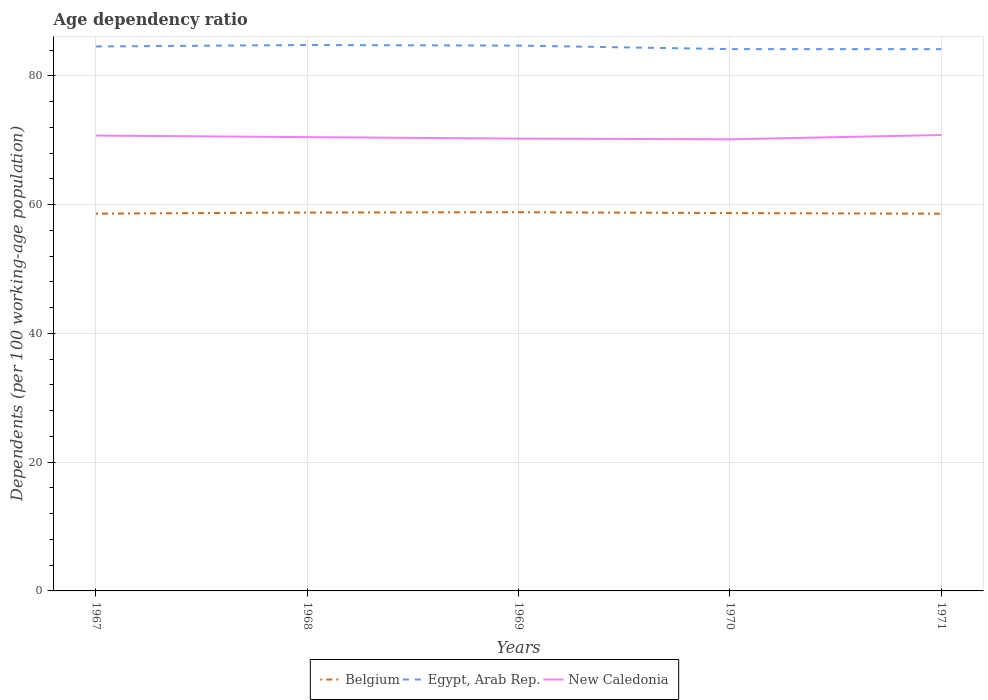Is the number of lines equal to the number of legend labels?
Ensure brevity in your answer.  Yes. Across all years, what is the maximum age dependency ratio in in Belgium?
Ensure brevity in your answer.  58.59. In which year was the age dependency ratio in in New Caledonia maximum?
Your answer should be very brief. 1970. What is the total age dependency ratio in in Belgium in the graph?
Ensure brevity in your answer.  -0.09. What is the difference between the highest and the second highest age dependency ratio in in New Caledonia?
Keep it short and to the point. 0.67. What is the difference between the highest and the lowest age dependency ratio in in Egypt, Arab Rep.?
Your answer should be compact. 3. Is the age dependency ratio in in Belgium strictly greater than the age dependency ratio in in Egypt, Arab Rep. over the years?
Your answer should be very brief. Yes. How many lines are there?
Offer a terse response. 3. Are the values on the major ticks of Y-axis written in scientific E-notation?
Your answer should be compact. No. Does the graph contain grids?
Your answer should be very brief. Yes. Where does the legend appear in the graph?
Offer a very short reply. Bottom center. What is the title of the graph?
Give a very brief answer. Age dependency ratio. What is the label or title of the X-axis?
Give a very brief answer. Years. What is the label or title of the Y-axis?
Offer a terse response. Dependents (per 100 working-age population). What is the Dependents (per 100 working-age population) of Belgium in 1967?
Your response must be concise. 58.6. What is the Dependents (per 100 working-age population) of Egypt, Arab Rep. in 1967?
Make the answer very short. 84.56. What is the Dependents (per 100 working-age population) in New Caledonia in 1967?
Your response must be concise. 70.73. What is the Dependents (per 100 working-age population) in Belgium in 1968?
Your answer should be very brief. 58.77. What is the Dependents (per 100 working-age population) of Egypt, Arab Rep. in 1968?
Provide a succinct answer. 84.79. What is the Dependents (per 100 working-age population) in New Caledonia in 1968?
Provide a succinct answer. 70.48. What is the Dependents (per 100 working-age population) in Belgium in 1969?
Ensure brevity in your answer.  58.82. What is the Dependents (per 100 working-age population) in Egypt, Arab Rep. in 1969?
Give a very brief answer. 84.7. What is the Dependents (per 100 working-age population) of New Caledonia in 1969?
Provide a succinct answer. 70.25. What is the Dependents (per 100 working-age population) in Belgium in 1970?
Offer a very short reply. 58.69. What is the Dependents (per 100 working-age population) of Egypt, Arab Rep. in 1970?
Your response must be concise. 84.16. What is the Dependents (per 100 working-age population) of New Caledonia in 1970?
Offer a terse response. 70.15. What is the Dependents (per 100 working-age population) of Belgium in 1971?
Offer a very short reply. 58.59. What is the Dependents (per 100 working-age population) of Egypt, Arab Rep. in 1971?
Keep it short and to the point. 84.15. What is the Dependents (per 100 working-age population) in New Caledonia in 1971?
Provide a short and direct response. 70.81. Across all years, what is the maximum Dependents (per 100 working-age population) of Belgium?
Offer a terse response. 58.82. Across all years, what is the maximum Dependents (per 100 working-age population) of Egypt, Arab Rep.?
Give a very brief answer. 84.79. Across all years, what is the maximum Dependents (per 100 working-age population) in New Caledonia?
Your answer should be very brief. 70.81. Across all years, what is the minimum Dependents (per 100 working-age population) of Belgium?
Your answer should be compact. 58.59. Across all years, what is the minimum Dependents (per 100 working-age population) in Egypt, Arab Rep.?
Offer a very short reply. 84.15. Across all years, what is the minimum Dependents (per 100 working-age population) of New Caledonia?
Your response must be concise. 70.15. What is the total Dependents (per 100 working-age population) in Belgium in the graph?
Your answer should be compact. 293.48. What is the total Dependents (per 100 working-age population) of Egypt, Arab Rep. in the graph?
Keep it short and to the point. 422.36. What is the total Dependents (per 100 working-age population) in New Caledonia in the graph?
Your response must be concise. 352.43. What is the difference between the Dependents (per 100 working-age population) of Belgium in 1967 and that in 1968?
Keep it short and to the point. -0.17. What is the difference between the Dependents (per 100 working-age population) of Egypt, Arab Rep. in 1967 and that in 1968?
Your answer should be very brief. -0.23. What is the difference between the Dependents (per 100 working-age population) in New Caledonia in 1967 and that in 1968?
Provide a short and direct response. 0.25. What is the difference between the Dependents (per 100 working-age population) of Belgium in 1967 and that in 1969?
Offer a very short reply. -0.22. What is the difference between the Dependents (per 100 working-age population) in Egypt, Arab Rep. in 1967 and that in 1969?
Keep it short and to the point. -0.13. What is the difference between the Dependents (per 100 working-age population) of New Caledonia in 1967 and that in 1969?
Offer a very short reply. 0.48. What is the difference between the Dependents (per 100 working-age population) in Belgium in 1967 and that in 1970?
Offer a very short reply. -0.09. What is the difference between the Dependents (per 100 working-age population) in Egypt, Arab Rep. in 1967 and that in 1970?
Make the answer very short. 0.41. What is the difference between the Dependents (per 100 working-age population) in New Caledonia in 1967 and that in 1970?
Give a very brief answer. 0.58. What is the difference between the Dependents (per 100 working-age population) of Belgium in 1967 and that in 1971?
Provide a succinct answer. 0.01. What is the difference between the Dependents (per 100 working-age population) of Egypt, Arab Rep. in 1967 and that in 1971?
Offer a terse response. 0.41. What is the difference between the Dependents (per 100 working-age population) in New Caledonia in 1967 and that in 1971?
Provide a short and direct response. -0.08. What is the difference between the Dependents (per 100 working-age population) of Belgium in 1968 and that in 1969?
Provide a short and direct response. -0.05. What is the difference between the Dependents (per 100 working-age population) in Egypt, Arab Rep. in 1968 and that in 1969?
Offer a terse response. 0.09. What is the difference between the Dependents (per 100 working-age population) in New Caledonia in 1968 and that in 1969?
Keep it short and to the point. 0.23. What is the difference between the Dependents (per 100 working-age population) of Belgium in 1968 and that in 1970?
Your answer should be very brief. 0.08. What is the difference between the Dependents (per 100 working-age population) in Egypt, Arab Rep. in 1968 and that in 1970?
Ensure brevity in your answer.  0.63. What is the difference between the Dependents (per 100 working-age population) in New Caledonia in 1968 and that in 1970?
Provide a succinct answer. 0.34. What is the difference between the Dependents (per 100 working-age population) of Belgium in 1968 and that in 1971?
Offer a very short reply. 0.18. What is the difference between the Dependents (per 100 working-age population) of Egypt, Arab Rep. in 1968 and that in 1971?
Your response must be concise. 0.64. What is the difference between the Dependents (per 100 working-age population) in New Caledonia in 1968 and that in 1971?
Offer a very short reply. -0.33. What is the difference between the Dependents (per 100 working-age population) of Belgium in 1969 and that in 1970?
Provide a short and direct response. 0.13. What is the difference between the Dependents (per 100 working-age population) of Egypt, Arab Rep. in 1969 and that in 1970?
Your response must be concise. 0.54. What is the difference between the Dependents (per 100 working-age population) of New Caledonia in 1969 and that in 1970?
Your answer should be compact. 0.11. What is the difference between the Dependents (per 100 working-age population) of Belgium in 1969 and that in 1971?
Offer a very short reply. 0.23. What is the difference between the Dependents (per 100 working-age population) in Egypt, Arab Rep. in 1969 and that in 1971?
Provide a short and direct response. 0.55. What is the difference between the Dependents (per 100 working-age population) of New Caledonia in 1969 and that in 1971?
Provide a succinct answer. -0.56. What is the difference between the Dependents (per 100 working-age population) in Belgium in 1970 and that in 1971?
Provide a succinct answer. 0.1. What is the difference between the Dependents (per 100 working-age population) of Egypt, Arab Rep. in 1970 and that in 1971?
Your response must be concise. 0.01. What is the difference between the Dependents (per 100 working-age population) in New Caledonia in 1970 and that in 1971?
Provide a short and direct response. -0.67. What is the difference between the Dependents (per 100 working-age population) of Belgium in 1967 and the Dependents (per 100 working-age population) of Egypt, Arab Rep. in 1968?
Your response must be concise. -26.19. What is the difference between the Dependents (per 100 working-age population) of Belgium in 1967 and the Dependents (per 100 working-age population) of New Caledonia in 1968?
Give a very brief answer. -11.88. What is the difference between the Dependents (per 100 working-age population) of Egypt, Arab Rep. in 1967 and the Dependents (per 100 working-age population) of New Caledonia in 1968?
Ensure brevity in your answer.  14.08. What is the difference between the Dependents (per 100 working-age population) in Belgium in 1967 and the Dependents (per 100 working-age population) in Egypt, Arab Rep. in 1969?
Your response must be concise. -26.1. What is the difference between the Dependents (per 100 working-age population) in Belgium in 1967 and the Dependents (per 100 working-age population) in New Caledonia in 1969?
Offer a very short reply. -11.65. What is the difference between the Dependents (per 100 working-age population) of Egypt, Arab Rep. in 1967 and the Dependents (per 100 working-age population) of New Caledonia in 1969?
Keep it short and to the point. 14.31. What is the difference between the Dependents (per 100 working-age population) in Belgium in 1967 and the Dependents (per 100 working-age population) in Egypt, Arab Rep. in 1970?
Your response must be concise. -25.56. What is the difference between the Dependents (per 100 working-age population) in Belgium in 1967 and the Dependents (per 100 working-age population) in New Caledonia in 1970?
Make the answer very short. -11.54. What is the difference between the Dependents (per 100 working-age population) in Egypt, Arab Rep. in 1967 and the Dependents (per 100 working-age population) in New Caledonia in 1970?
Keep it short and to the point. 14.42. What is the difference between the Dependents (per 100 working-age population) in Belgium in 1967 and the Dependents (per 100 working-age population) in Egypt, Arab Rep. in 1971?
Keep it short and to the point. -25.55. What is the difference between the Dependents (per 100 working-age population) of Belgium in 1967 and the Dependents (per 100 working-age population) of New Caledonia in 1971?
Provide a short and direct response. -12.21. What is the difference between the Dependents (per 100 working-age population) of Egypt, Arab Rep. in 1967 and the Dependents (per 100 working-age population) of New Caledonia in 1971?
Your answer should be compact. 13.75. What is the difference between the Dependents (per 100 working-age population) of Belgium in 1968 and the Dependents (per 100 working-age population) of Egypt, Arab Rep. in 1969?
Your answer should be very brief. -25.92. What is the difference between the Dependents (per 100 working-age population) in Belgium in 1968 and the Dependents (per 100 working-age population) in New Caledonia in 1969?
Provide a short and direct response. -11.48. What is the difference between the Dependents (per 100 working-age population) of Egypt, Arab Rep. in 1968 and the Dependents (per 100 working-age population) of New Caledonia in 1969?
Offer a terse response. 14.54. What is the difference between the Dependents (per 100 working-age population) in Belgium in 1968 and the Dependents (per 100 working-age population) in Egypt, Arab Rep. in 1970?
Your answer should be compact. -25.38. What is the difference between the Dependents (per 100 working-age population) of Belgium in 1968 and the Dependents (per 100 working-age population) of New Caledonia in 1970?
Offer a very short reply. -11.37. What is the difference between the Dependents (per 100 working-age population) of Egypt, Arab Rep. in 1968 and the Dependents (per 100 working-age population) of New Caledonia in 1970?
Make the answer very short. 14.65. What is the difference between the Dependents (per 100 working-age population) in Belgium in 1968 and the Dependents (per 100 working-age population) in Egypt, Arab Rep. in 1971?
Provide a succinct answer. -25.38. What is the difference between the Dependents (per 100 working-age population) of Belgium in 1968 and the Dependents (per 100 working-age population) of New Caledonia in 1971?
Your answer should be compact. -12.04. What is the difference between the Dependents (per 100 working-age population) of Egypt, Arab Rep. in 1968 and the Dependents (per 100 working-age population) of New Caledonia in 1971?
Your response must be concise. 13.98. What is the difference between the Dependents (per 100 working-age population) of Belgium in 1969 and the Dependents (per 100 working-age population) of Egypt, Arab Rep. in 1970?
Ensure brevity in your answer.  -25.34. What is the difference between the Dependents (per 100 working-age population) in Belgium in 1969 and the Dependents (per 100 working-age population) in New Caledonia in 1970?
Provide a short and direct response. -11.33. What is the difference between the Dependents (per 100 working-age population) of Egypt, Arab Rep. in 1969 and the Dependents (per 100 working-age population) of New Caledonia in 1970?
Keep it short and to the point. 14.55. What is the difference between the Dependents (per 100 working-age population) of Belgium in 1969 and the Dependents (per 100 working-age population) of Egypt, Arab Rep. in 1971?
Keep it short and to the point. -25.33. What is the difference between the Dependents (per 100 working-age population) in Belgium in 1969 and the Dependents (per 100 working-age population) in New Caledonia in 1971?
Offer a very short reply. -11.99. What is the difference between the Dependents (per 100 working-age population) of Egypt, Arab Rep. in 1969 and the Dependents (per 100 working-age population) of New Caledonia in 1971?
Keep it short and to the point. 13.88. What is the difference between the Dependents (per 100 working-age population) in Belgium in 1970 and the Dependents (per 100 working-age population) in Egypt, Arab Rep. in 1971?
Your response must be concise. -25.46. What is the difference between the Dependents (per 100 working-age population) of Belgium in 1970 and the Dependents (per 100 working-age population) of New Caledonia in 1971?
Offer a very short reply. -12.12. What is the difference between the Dependents (per 100 working-age population) of Egypt, Arab Rep. in 1970 and the Dependents (per 100 working-age population) of New Caledonia in 1971?
Offer a very short reply. 13.34. What is the average Dependents (per 100 working-age population) in Belgium per year?
Offer a terse response. 58.7. What is the average Dependents (per 100 working-age population) in Egypt, Arab Rep. per year?
Offer a very short reply. 84.47. What is the average Dependents (per 100 working-age population) in New Caledonia per year?
Your answer should be very brief. 70.49. In the year 1967, what is the difference between the Dependents (per 100 working-age population) of Belgium and Dependents (per 100 working-age population) of Egypt, Arab Rep.?
Make the answer very short. -25.96. In the year 1967, what is the difference between the Dependents (per 100 working-age population) in Belgium and Dependents (per 100 working-age population) in New Caledonia?
Keep it short and to the point. -12.13. In the year 1967, what is the difference between the Dependents (per 100 working-age population) in Egypt, Arab Rep. and Dependents (per 100 working-age population) in New Caledonia?
Provide a short and direct response. 13.83. In the year 1968, what is the difference between the Dependents (per 100 working-age population) of Belgium and Dependents (per 100 working-age population) of Egypt, Arab Rep.?
Your answer should be very brief. -26.02. In the year 1968, what is the difference between the Dependents (per 100 working-age population) in Belgium and Dependents (per 100 working-age population) in New Caledonia?
Your response must be concise. -11.71. In the year 1968, what is the difference between the Dependents (per 100 working-age population) in Egypt, Arab Rep. and Dependents (per 100 working-age population) in New Caledonia?
Give a very brief answer. 14.31. In the year 1969, what is the difference between the Dependents (per 100 working-age population) of Belgium and Dependents (per 100 working-age population) of Egypt, Arab Rep.?
Provide a succinct answer. -25.88. In the year 1969, what is the difference between the Dependents (per 100 working-age population) in Belgium and Dependents (per 100 working-age population) in New Caledonia?
Provide a succinct answer. -11.43. In the year 1969, what is the difference between the Dependents (per 100 working-age population) of Egypt, Arab Rep. and Dependents (per 100 working-age population) of New Caledonia?
Provide a short and direct response. 14.44. In the year 1970, what is the difference between the Dependents (per 100 working-age population) of Belgium and Dependents (per 100 working-age population) of Egypt, Arab Rep.?
Offer a terse response. -25.47. In the year 1970, what is the difference between the Dependents (per 100 working-age population) of Belgium and Dependents (per 100 working-age population) of New Caledonia?
Offer a terse response. -11.46. In the year 1970, what is the difference between the Dependents (per 100 working-age population) of Egypt, Arab Rep. and Dependents (per 100 working-age population) of New Caledonia?
Your answer should be compact. 14.01. In the year 1971, what is the difference between the Dependents (per 100 working-age population) of Belgium and Dependents (per 100 working-age population) of Egypt, Arab Rep.?
Your answer should be compact. -25.56. In the year 1971, what is the difference between the Dependents (per 100 working-age population) in Belgium and Dependents (per 100 working-age population) in New Caledonia?
Ensure brevity in your answer.  -12.22. In the year 1971, what is the difference between the Dependents (per 100 working-age population) in Egypt, Arab Rep. and Dependents (per 100 working-age population) in New Caledonia?
Ensure brevity in your answer.  13.34. What is the ratio of the Dependents (per 100 working-age population) of Egypt, Arab Rep. in 1967 to that in 1968?
Your response must be concise. 1. What is the ratio of the Dependents (per 100 working-age population) in New Caledonia in 1967 to that in 1968?
Keep it short and to the point. 1. What is the ratio of the Dependents (per 100 working-age population) of Egypt, Arab Rep. in 1967 to that in 1969?
Offer a very short reply. 1. What is the ratio of the Dependents (per 100 working-age population) in New Caledonia in 1967 to that in 1969?
Offer a very short reply. 1.01. What is the ratio of the Dependents (per 100 working-age population) of Egypt, Arab Rep. in 1967 to that in 1970?
Ensure brevity in your answer.  1. What is the ratio of the Dependents (per 100 working-age population) in New Caledonia in 1967 to that in 1970?
Ensure brevity in your answer.  1.01. What is the ratio of the Dependents (per 100 working-age population) of Egypt, Arab Rep. in 1967 to that in 1971?
Your response must be concise. 1. What is the ratio of the Dependents (per 100 working-age population) in New Caledonia in 1967 to that in 1971?
Keep it short and to the point. 1. What is the ratio of the Dependents (per 100 working-age population) of Belgium in 1968 to that in 1970?
Keep it short and to the point. 1. What is the ratio of the Dependents (per 100 working-age population) of Egypt, Arab Rep. in 1968 to that in 1970?
Give a very brief answer. 1.01. What is the ratio of the Dependents (per 100 working-age population) in New Caledonia in 1968 to that in 1970?
Make the answer very short. 1. What is the ratio of the Dependents (per 100 working-age population) in Belgium in 1968 to that in 1971?
Your answer should be compact. 1. What is the ratio of the Dependents (per 100 working-age population) of Egypt, Arab Rep. in 1968 to that in 1971?
Offer a very short reply. 1.01. What is the ratio of the Dependents (per 100 working-age population) of Egypt, Arab Rep. in 1969 to that in 1970?
Your response must be concise. 1.01. What is the ratio of the Dependents (per 100 working-age population) in Belgium in 1969 to that in 1971?
Keep it short and to the point. 1. What is the ratio of the Dependents (per 100 working-age population) of New Caledonia in 1969 to that in 1971?
Your answer should be compact. 0.99. What is the ratio of the Dependents (per 100 working-age population) in Egypt, Arab Rep. in 1970 to that in 1971?
Keep it short and to the point. 1. What is the ratio of the Dependents (per 100 working-age population) of New Caledonia in 1970 to that in 1971?
Make the answer very short. 0.99. What is the difference between the highest and the second highest Dependents (per 100 working-age population) in Belgium?
Offer a very short reply. 0.05. What is the difference between the highest and the second highest Dependents (per 100 working-age population) of Egypt, Arab Rep.?
Provide a succinct answer. 0.09. What is the difference between the highest and the second highest Dependents (per 100 working-age population) in New Caledonia?
Offer a very short reply. 0.08. What is the difference between the highest and the lowest Dependents (per 100 working-age population) of Belgium?
Give a very brief answer. 0.23. What is the difference between the highest and the lowest Dependents (per 100 working-age population) of Egypt, Arab Rep.?
Your answer should be very brief. 0.64. What is the difference between the highest and the lowest Dependents (per 100 working-age population) in New Caledonia?
Offer a terse response. 0.67. 